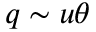Convert formula to latex. <formula><loc_0><loc_0><loc_500><loc_500>q \sim u \theta</formula> 